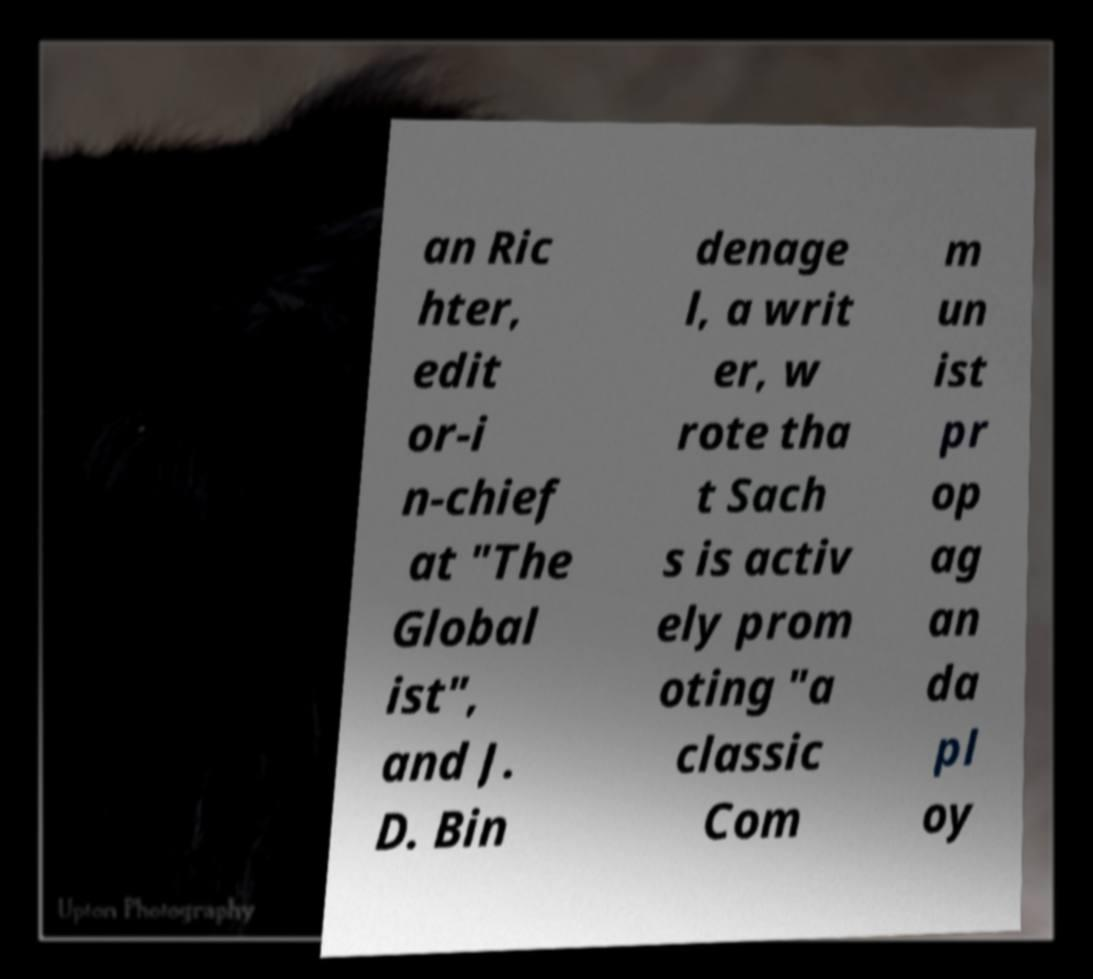Could you extract and type out the text from this image? an Ric hter, edit or-i n-chief at "The Global ist", and J. D. Bin denage l, a writ er, w rote tha t Sach s is activ ely prom oting "a classic Com m un ist pr op ag an da pl oy 